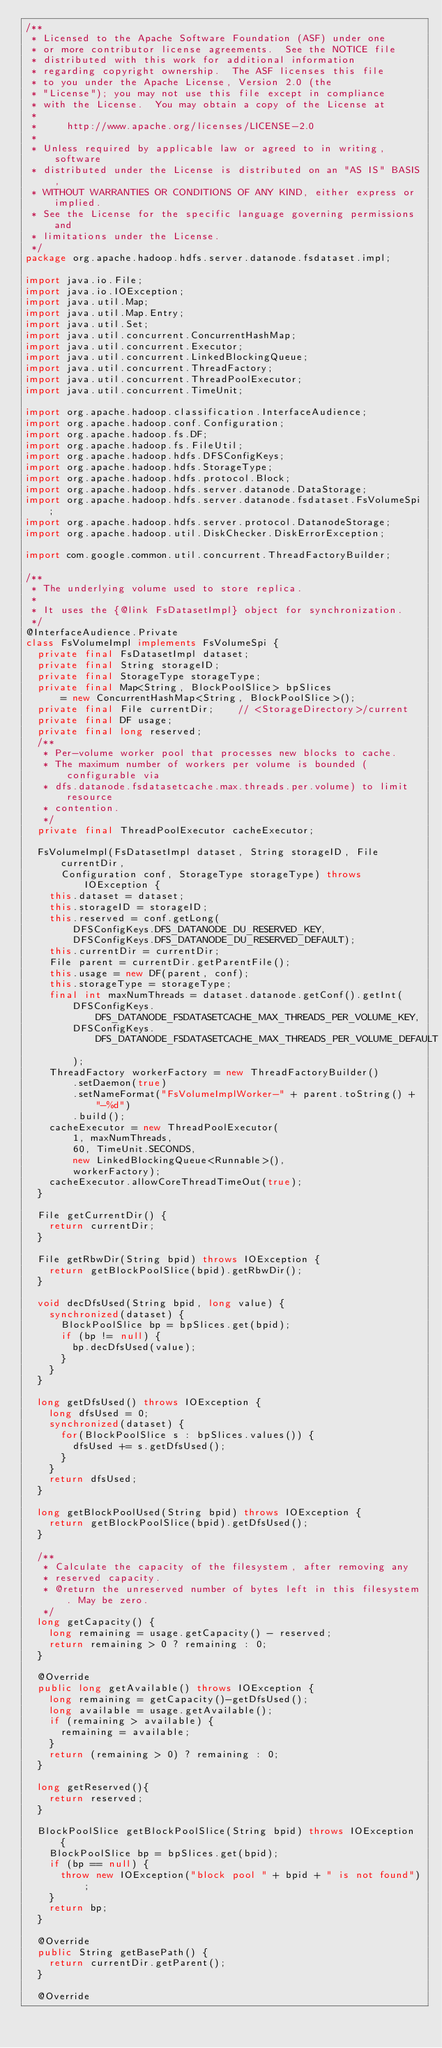Convert code to text. <code><loc_0><loc_0><loc_500><loc_500><_Java_>/**
 * Licensed to the Apache Software Foundation (ASF) under one
 * or more contributor license agreements.  See the NOTICE file
 * distributed with this work for additional information
 * regarding copyright ownership.  The ASF licenses this file
 * to you under the Apache License, Version 2.0 (the
 * "License"); you may not use this file except in compliance
 * with the License.  You may obtain a copy of the License at
 *
 *     http://www.apache.org/licenses/LICENSE-2.0
 *
 * Unless required by applicable law or agreed to in writing, software
 * distributed under the License is distributed on an "AS IS" BASIS,
 * WITHOUT WARRANTIES OR CONDITIONS OF ANY KIND, either express or implied.
 * See the License for the specific language governing permissions and
 * limitations under the License.
 */
package org.apache.hadoop.hdfs.server.datanode.fsdataset.impl;

import java.io.File;
import java.io.IOException;
import java.util.Map;
import java.util.Map.Entry;
import java.util.Set;
import java.util.concurrent.ConcurrentHashMap;
import java.util.concurrent.Executor;
import java.util.concurrent.LinkedBlockingQueue;
import java.util.concurrent.ThreadFactory;
import java.util.concurrent.ThreadPoolExecutor;
import java.util.concurrent.TimeUnit;

import org.apache.hadoop.classification.InterfaceAudience;
import org.apache.hadoop.conf.Configuration;
import org.apache.hadoop.fs.DF;
import org.apache.hadoop.fs.FileUtil;
import org.apache.hadoop.hdfs.DFSConfigKeys;
import org.apache.hadoop.hdfs.StorageType;
import org.apache.hadoop.hdfs.protocol.Block;
import org.apache.hadoop.hdfs.server.datanode.DataStorage;
import org.apache.hadoop.hdfs.server.datanode.fsdataset.FsVolumeSpi;
import org.apache.hadoop.hdfs.server.protocol.DatanodeStorage;
import org.apache.hadoop.util.DiskChecker.DiskErrorException;

import com.google.common.util.concurrent.ThreadFactoryBuilder;

/**
 * The underlying volume used to store replica.
 * 
 * It uses the {@link FsDatasetImpl} object for synchronization.
 */
@InterfaceAudience.Private
class FsVolumeImpl implements FsVolumeSpi {
  private final FsDatasetImpl dataset;
  private final String storageID;
  private final StorageType storageType;
  private final Map<String, BlockPoolSlice> bpSlices
      = new ConcurrentHashMap<String, BlockPoolSlice>();
  private final File currentDir;    // <StorageDirectory>/current
  private final DF usage;           
  private final long reserved;
  /**
   * Per-volume worker pool that processes new blocks to cache.
   * The maximum number of workers per volume is bounded (configurable via
   * dfs.datanode.fsdatasetcache.max.threads.per.volume) to limit resource
   * contention.
   */
  private final ThreadPoolExecutor cacheExecutor;
  
  FsVolumeImpl(FsDatasetImpl dataset, String storageID, File currentDir,
      Configuration conf, StorageType storageType) throws IOException {
    this.dataset = dataset;
    this.storageID = storageID;
    this.reserved = conf.getLong(
        DFSConfigKeys.DFS_DATANODE_DU_RESERVED_KEY,
        DFSConfigKeys.DFS_DATANODE_DU_RESERVED_DEFAULT);
    this.currentDir = currentDir; 
    File parent = currentDir.getParentFile();
    this.usage = new DF(parent, conf);
    this.storageType = storageType;
    final int maxNumThreads = dataset.datanode.getConf().getInt(
        DFSConfigKeys.DFS_DATANODE_FSDATASETCACHE_MAX_THREADS_PER_VOLUME_KEY,
        DFSConfigKeys.DFS_DATANODE_FSDATASETCACHE_MAX_THREADS_PER_VOLUME_DEFAULT
        );
    ThreadFactory workerFactory = new ThreadFactoryBuilder()
        .setDaemon(true)
        .setNameFormat("FsVolumeImplWorker-" + parent.toString() + "-%d")
        .build();
    cacheExecutor = new ThreadPoolExecutor(
        1, maxNumThreads,
        60, TimeUnit.SECONDS,
        new LinkedBlockingQueue<Runnable>(),
        workerFactory);
    cacheExecutor.allowCoreThreadTimeOut(true);
  }
  
  File getCurrentDir() {
    return currentDir;
  }
  
  File getRbwDir(String bpid) throws IOException {
    return getBlockPoolSlice(bpid).getRbwDir();
  }
  
  void decDfsUsed(String bpid, long value) {
    synchronized(dataset) {
      BlockPoolSlice bp = bpSlices.get(bpid);
      if (bp != null) {
        bp.decDfsUsed(value);
      }
    }
  }
  
  long getDfsUsed() throws IOException {
    long dfsUsed = 0;
    synchronized(dataset) {
      for(BlockPoolSlice s : bpSlices.values()) {
        dfsUsed += s.getDfsUsed();
      }
    }
    return dfsUsed;
  }

  long getBlockPoolUsed(String bpid) throws IOException {
    return getBlockPoolSlice(bpid).getDfsUsed();
  }
  
  /**
   * Calculate the capacity of the filesystem, after removing any
   * reserved capacity.
   * @return the unreserved number of bytes left in this filesystem. May be zero.
   */
  long getCapacity() {
    long remaining = usage.getCapacity() - reserved;
    return remaining > 0 ? remaining : 0;
  }

  @Override
  public long getAvailable() throws IOException {
    long remaining = getCapacity()-getDfsUsed();
    long available = usage.getAvailable();
    if (remaining > available) {
      remaining = available;
    }
    return (remaining > 0) ? remaining : 0;
  }
    
  long getReserved(){
    return reserved;
  }

  BlockPoolSlice getBlockPoolSlice(String bpid) throws IOException {
    BlockPoolSlice bp = bpSlices.get(bpid);
    if (bp == null) {
      throw new IOException("block pool " + bpid + " is not found");
    }
    return bp;
  }

  @Override
  public String getBasePath() {
    return currentDir.getParent();
  }
  
  @Override</code> 